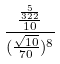<formula> <loc_0><loc_0><loc_500><loc_500>\frac { \frac { \frac { 5 } { 3 2 2 } } { 1 0 } } { ( \frac { \sqrt { 1 0 } } { 7 0 } ) ^ { 8 } }</formula> 